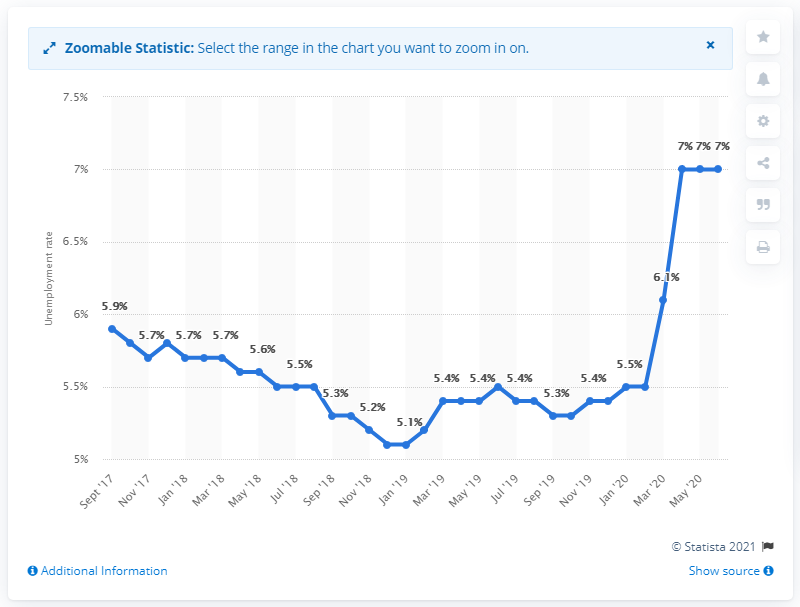What potential impact could this sharp rise in unemployment have on the Luxembourg economy? A sharp rise in unemployment can lead to reduced consumer spending and demand, which in turn could slow economic growth. It can also lead to increased government spending on social support services and potential political pressure to address the job market's instability. 